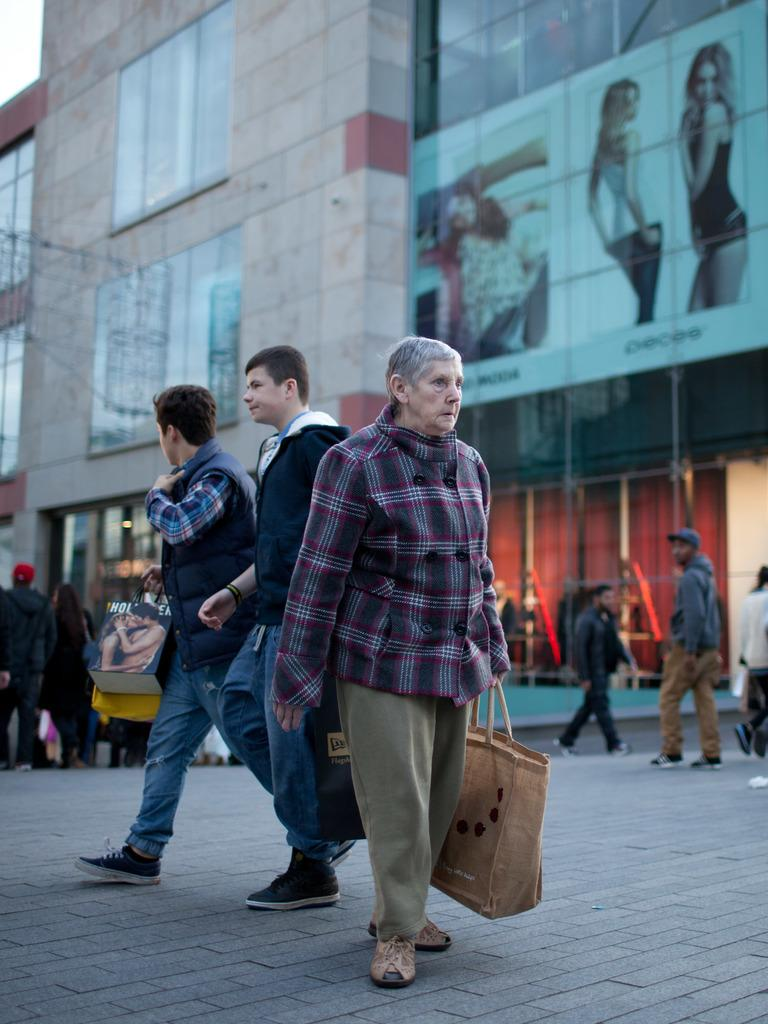What are the people in the image doing? The people in the image are walking. What can be seen in the distance behind the people? There is a building in the background of the image. What type of alley can be seen in the image? There is no alley present in the image; it features people walking and a building in the background. 